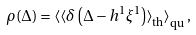Convert formula to latex. <formula><loc_0><loc_0><loc_500><loc_500>\rho ( \Delta ) = \left < \left < \delta \left ( \Delta - h ^ { 1 } \xi ^ { 1 } \right ) \right > _ { \text {th} } \right > _ { \text {qu} } ,</formula> 